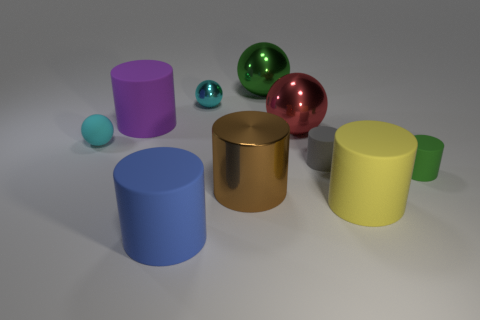What number of rubber objects have the same color as the small shiny sphere?
Your answer should be very brief. 1. What is the material of the large red thing?
Provide a short and direct response. Metal. Do the green matte thing and the yellow matte cylinder have the same size?
Ensure brevity in your answer.  No. What number of cylinders are big blue rubber objects or big metal objects?
Give a very brief answer. 2. The big rubber cylinder that is behind the green thing in front of the green metal object is what color?
Provide a short and direct response. Purple. Is the number of big blue rubber things on the right side of the tiny gray thing less than the number of tiny rubber objects in front of the large shiny cylinder?
Ensure brevity in your answer.  No. Does the blue rubber cylinder have the same size as the metallic ball that is to the left of the shiny cylinder?
Offer a very short reply. No. There is a thing that is right of the large brown metallic cylinder and behind the big purple rubber thing; what is its shape?
Your answer should be very brief. Sphere. There is a brown cylinder that is the same material as the green ball; what size is it?
Your answer should be very brief. Large. How many tiny metal balls are on the right side of the big matte thing behind the cyan rubber thing?
Keep it short and to the point. 1. 